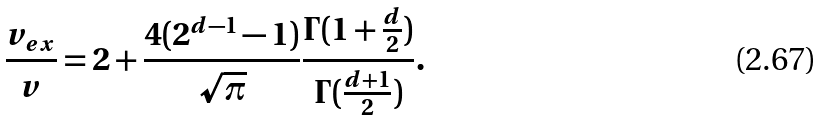Convert formula to latex. <formula><loc_0><loc_0><loc_500><loc_500>\frac { v _ { e x } } { v } = 2 + \frac { 4 ( 2 ^ { d - 1 } - 1 ) } { \sqrt { \pi } } \frac { \Gamma ( 1 + \frac { d } { 2 } ) } { \Gamma ( \frac { d + 1 } { 2 } ) } .</formula> 